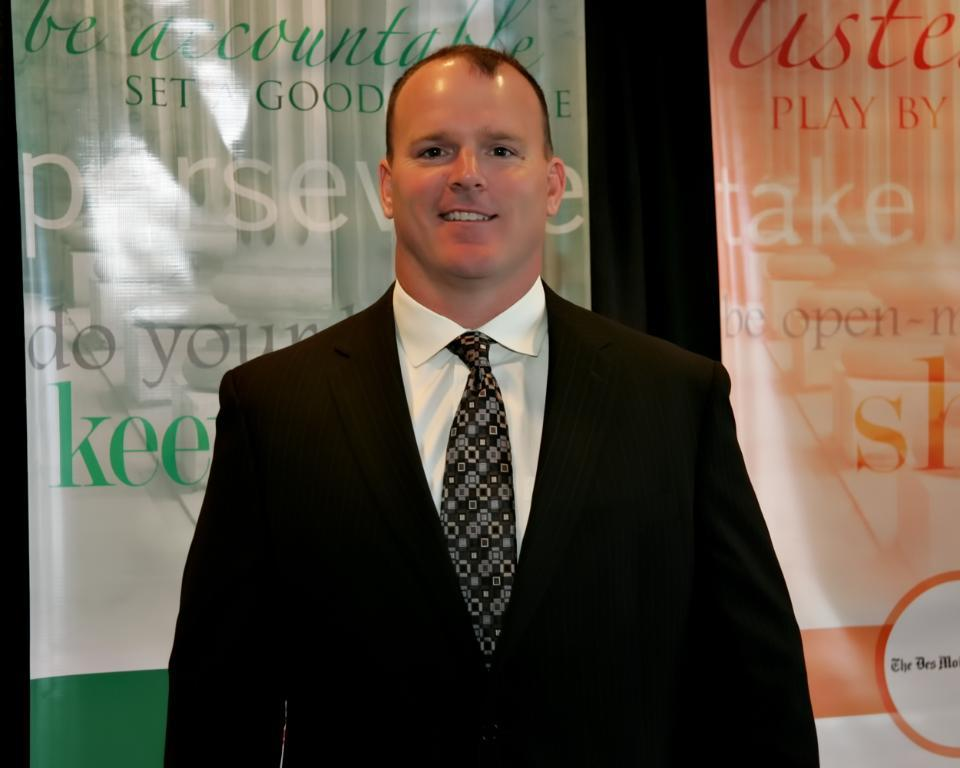Who is in the image? There is a person in the image. What is the person doing in the image? The person is standing. What is the person's facial expression in the image? The person is smiling. What else can be seen in the image besides the person? There is a banner in the image. What is written on the banner? The banner has text on it. How many trucks can be seen driving on vacation in the image? There are no trucks or any indication of a vacation in the image. 